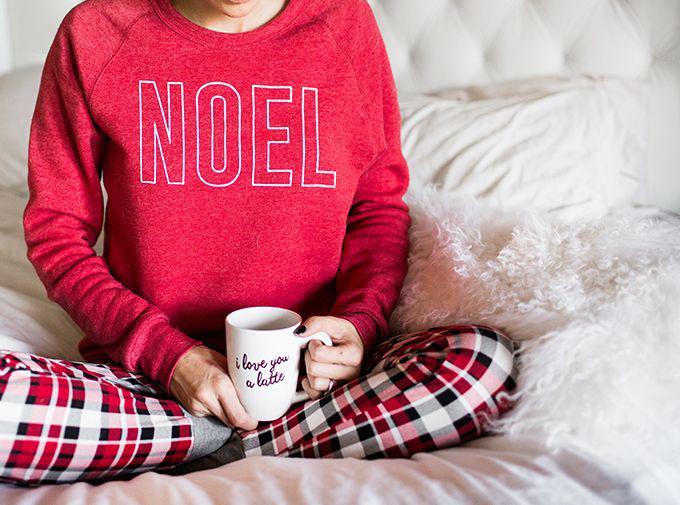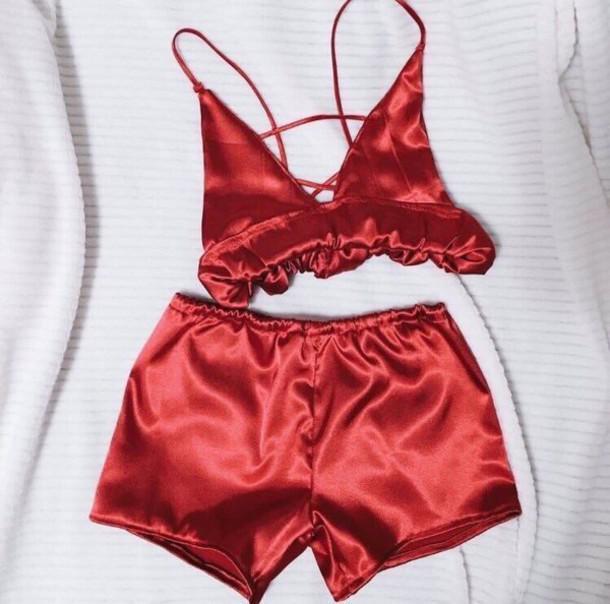The first image is the image on the left, the second image is the image on the right. For the images displayed, is the sentence "The right image contains at least one person dressed in sleep attire." factually correct? Answer yes or no. No. The first image is the image on the left, the second image is the image on the right. Examine the images to the left and right. Is the description "At least one pair of pajamas in both images feature a plaid bottom." accurate? Answer yes or no. No. 